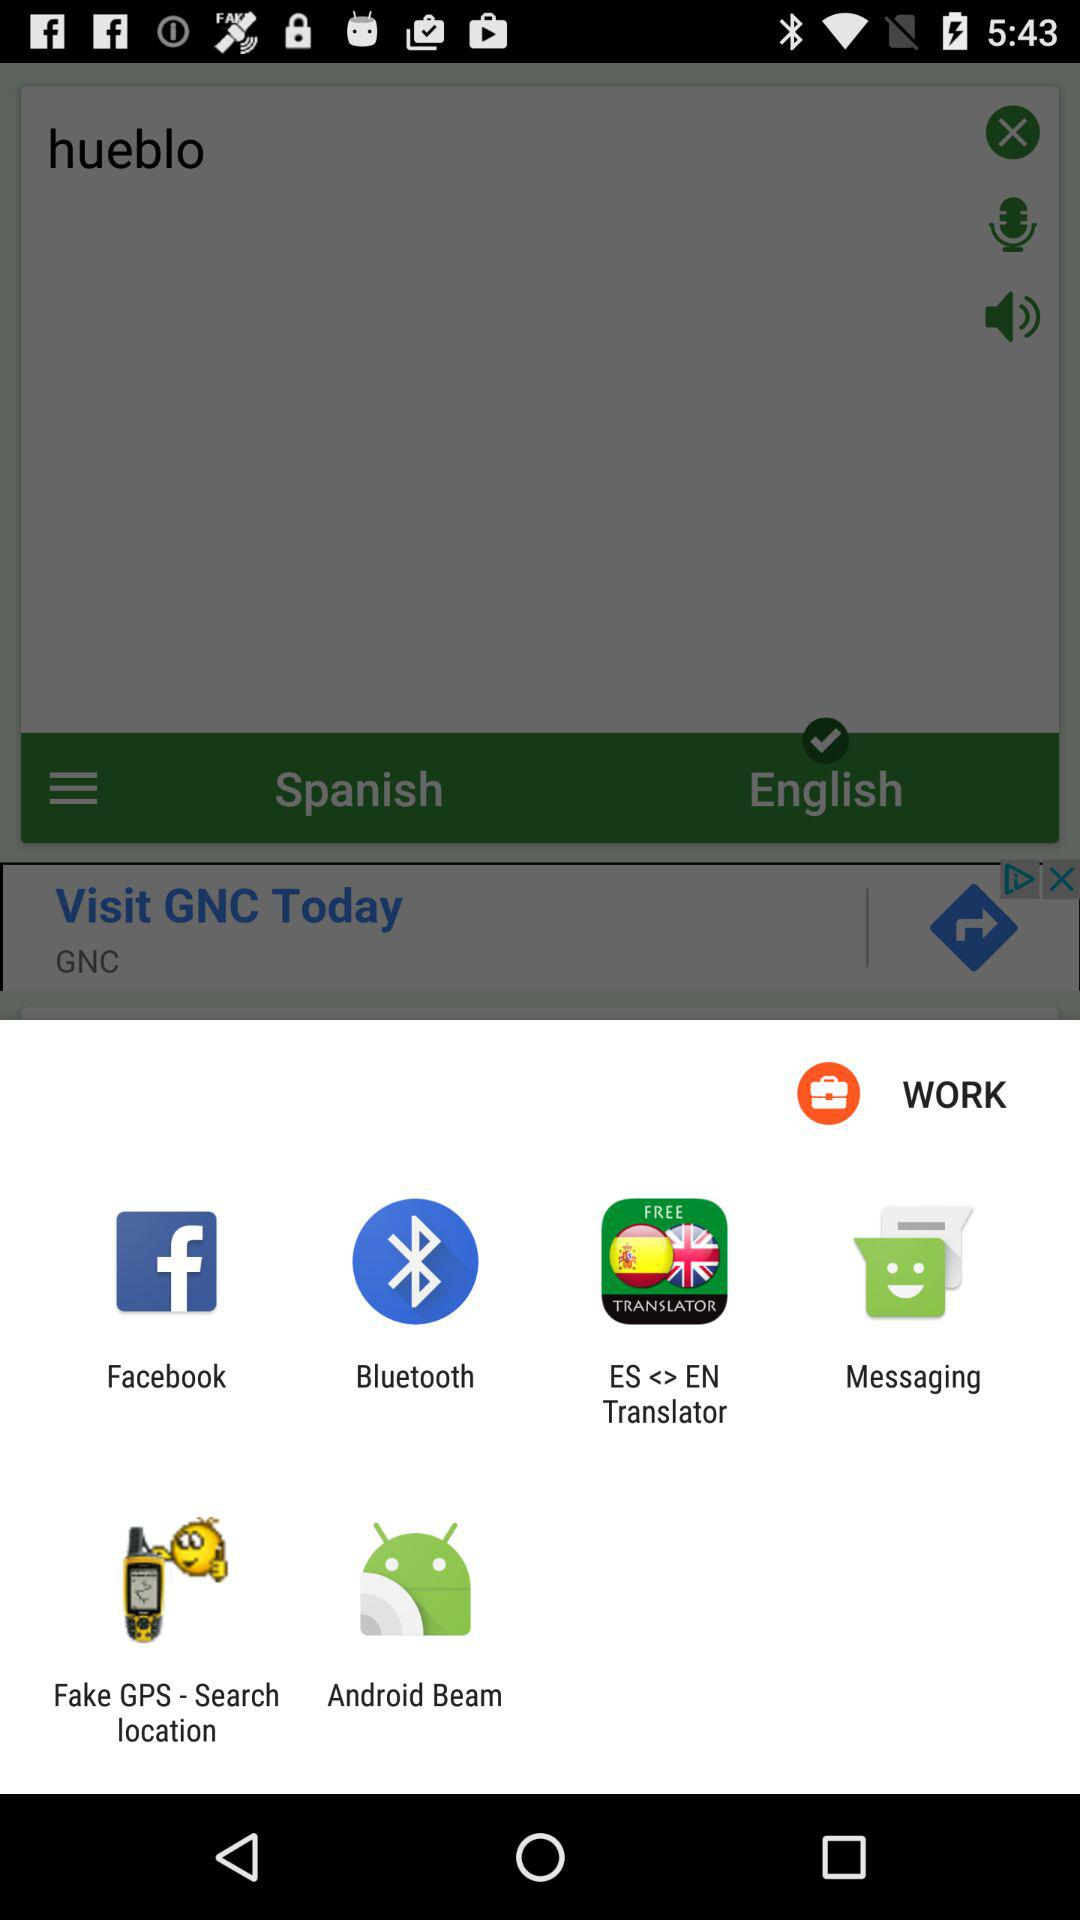Which options are given? The given options are "Facebook", "Bluetooth", "ES <> EN Translator", "Messaging", "Fake GPS - Search location" and "Android Beam". 